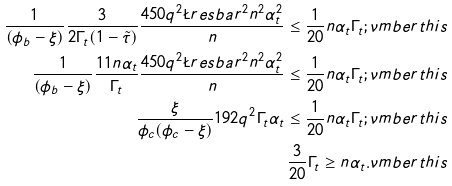<formula> <loc_0><loc_0><loc_500><loc_500>\frac { 1 } { ( \phi _ { b } - \xi ) } \frac { 3 } { 2 \Gamma _ { t } ( 1 - \tilde { \tau } ) } \frac { 4 5 0 q ^ { 2 } \L r e s b a r ^ { 2 } n ^ { 2 } \alpha _ { t } ^ { 2 } } { n } \leq \frac { 1 } { 2 0 } n \alpha _ { t } \Gamma _ { t } ; \nu m b e r t h i s \\ \frac { 1 } { ( \phi _ { b } - \xi ) } \frac { 1 1 n \alpha _ { t } } { \Gamma _ { t } } \frac { 4 5 0 q ^ { 2 } \L r e s b a r ^ { 2 } n ^ { 2 } \alpha _ { t } ^ { 2 } } { n } \leq \frac { 1 } { 2 0 } n \alpha _ { t } \Gamma _ { t } ; \nu m b e r t h i s \\ \frac { \xi } { \phi _ { c } ( \phi _ { c } - \xi ) } 1 9 2 q ^ { 2 } \Gamma _ { t } \alpha _ { t } \leq \frac { 1 } { 2 0 } n \alpha _ { t } \Gamma _ { t } ; \nu m b e r t h i s \\ \frac { 3 } { 2 0 } \Gamma _ { t } \geq n \alpha _ { t } . \nu m b e r t h i s</formula> 